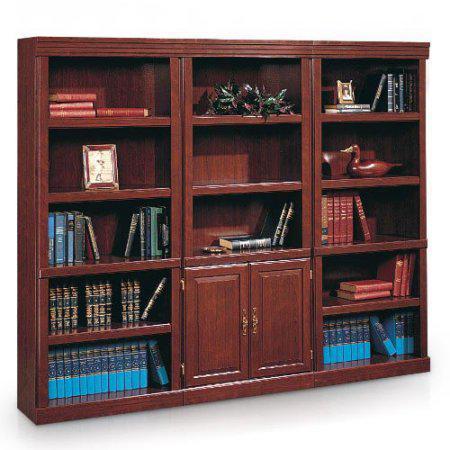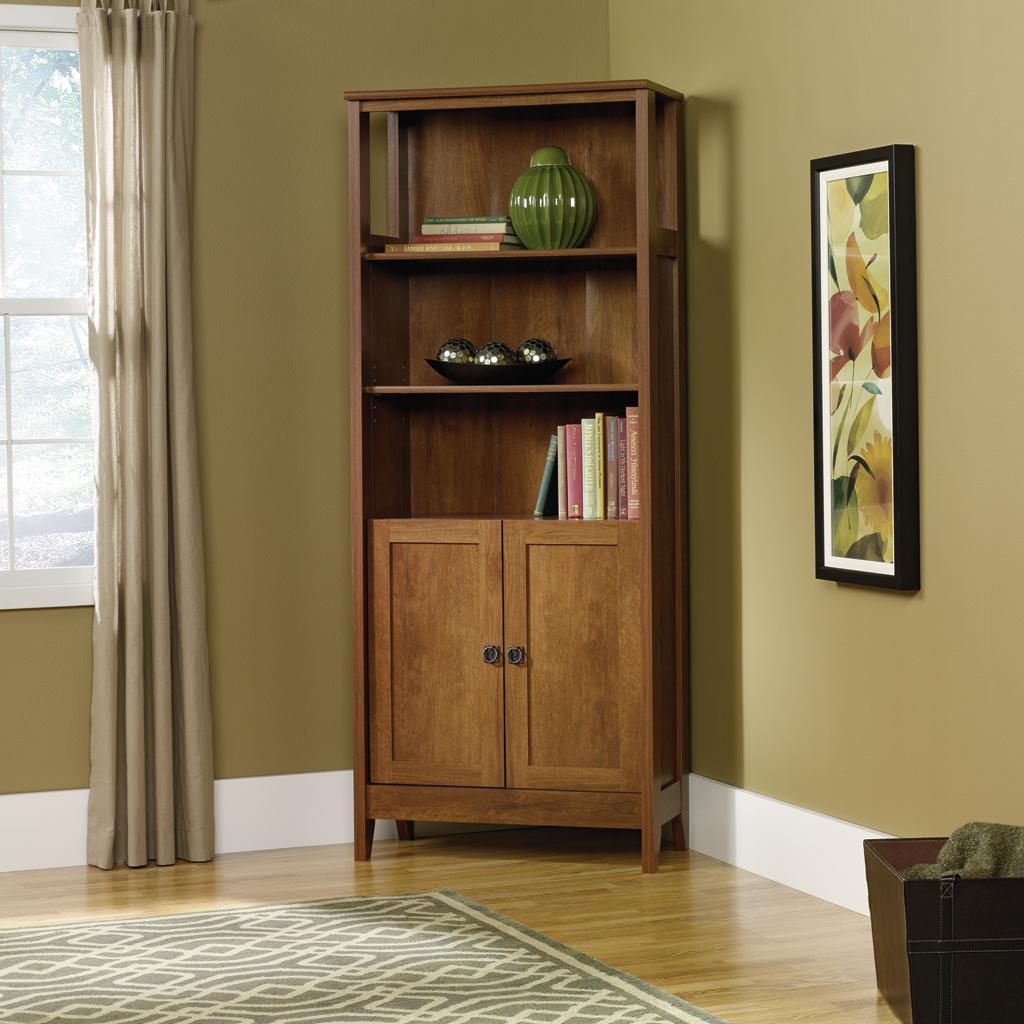The first image is the image on the left, the second image is the image on the right. For the images shown, is this caption "In at least one image, there is a window with a curtain to the left of a bookcase." true? Answer yes or no. Yes. The first image is the image on the left, the second image is the image on the right. Evaluate the accuracy of this statement regarding the images: "There is one skinny bookshelf in the right image and one larger bookshelf in the left image.". Is it true? Answer yes or no. Yes. 